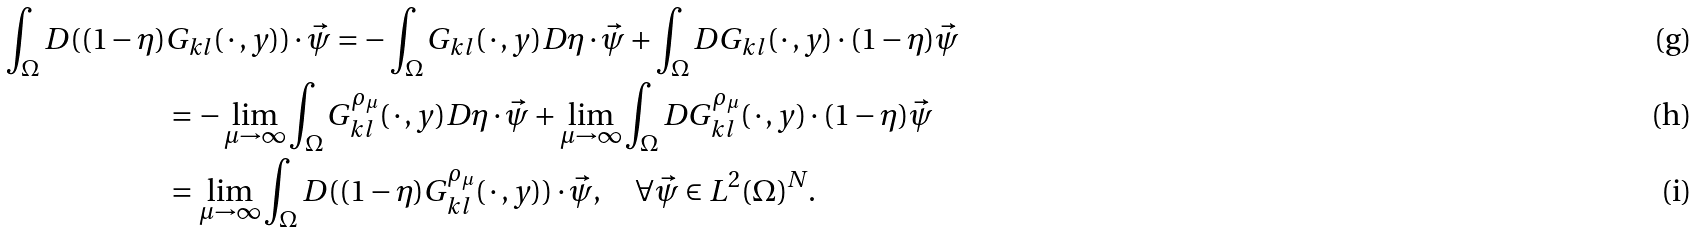<formula> <loc_0><loc_0><loc_500><loc_500>\int _ { \Omega } D ( ( 1 - \eta ) & G _ { k l } ( \, \cdot \, , y ) ) \cdot \vec { \psi } = - \int _ { \Omega } G _ { k l } ( \, \cdot \, , y ) D \eta \cdot \vec { \psi } + \int _ { \Omega } D G _ { k l } ( \, \cdot \, , y ) \cdot ( 1 - \eta ) \vec { \psi } \\ & = - \lim _ { \mu \to \infty } \int _ { \Omega } G _ { k l } ^ { \rho _ { \mu } } ( \, \cdot \, , y ) D \eta \cdot \vec { \psi } + \lim _ { \mu \to \infty } \int _ { \Omega } D G _ { k l } ^ { \rho _ { \mu } } ( \, \cdot \, , y ) \cdot ( 1 - \eta ) \vec { \psi } \\ & = \lim _ { \mu \to \infty } \int _ { \Omega } D ( ( 1 - \eta ) G _ { k l } ^ { \rho _ { \mu } } ( \, \cdot \, , y ) ) \cdot \vec { \psi } , \quad \forall \vec { \psi } \in L ^ { 2 } ( \Omega ) ^ { N } .</formula> 